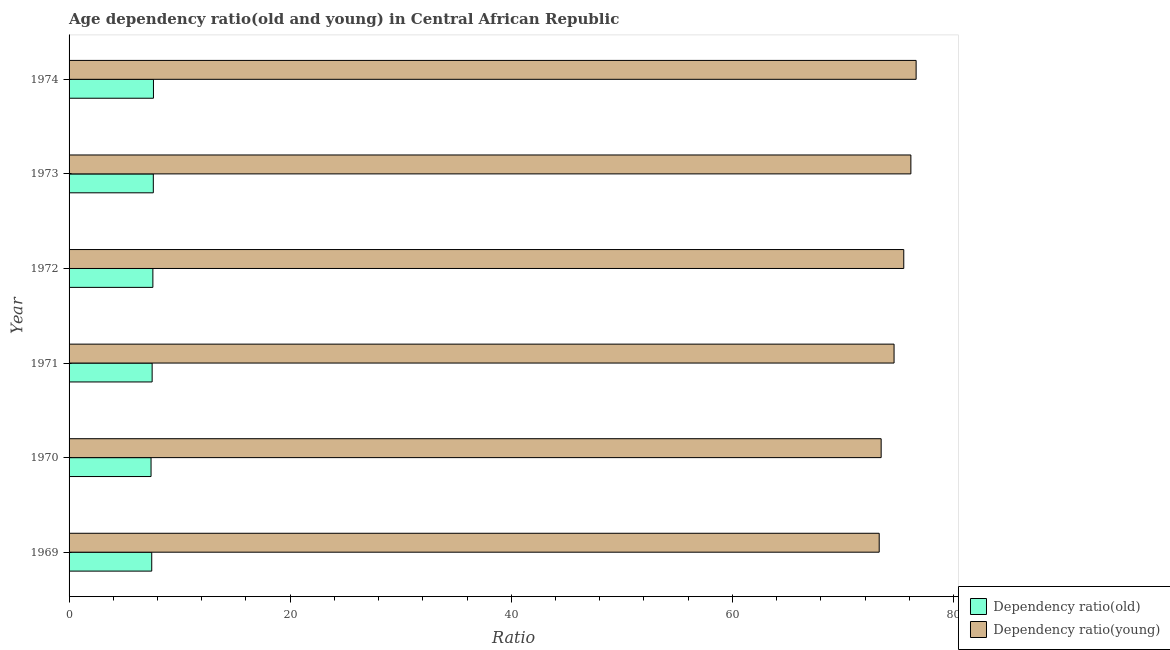How many groups of bars are there?
Make the answer very short. 6. What is the age dependency ratio(young) in 1969?
Provide a short and direct response. 73.27. Across all years, what is the maximum age dependency ratio(old)?
Your answer should be compact. 7.63. Across all years, what is the minimum age dependency ratio(young)?
Provide a short and direct response. 73.27. In which year was the age dependency ratio(old) maximum?
Keep it short and to the point. 1974. In which year was the age dependency ratio(young) minimum?
Your answer should be compact. 1969. What is the total age dependency ratio(young) in the graph?
Your answer should be compact. 449.59. What is the difference between the age dependency ratio(old) in 1969 and that in 1972?
Give a very brief answer. -0.1. What is the difference between the age dependency ratio(young) in 1973 and the age dependency ratio(old) in 1969?
Offer a very short reply. 68.66. What is the average age dependency ratio(old) per year?
Give a very brief answer. 7.54. In the year 1973, what is the difference between the age dependency ratio(young) and age dependency ratio(old)?
Provide a short and direct response. 68.52. In how many years, is the age dependency ratio(old) greater than 68 ?
Offer a terse response. 0. What is the ratio of the age dependency ratio(young) in 1970 to that in 1972?
Give a very brief answer. 0.97. Is the difference between the age dependency ratio(old) in 1972 and 1973 greater than the difference between the age dependency ratio(young) in 1972 and 1973?
Provide a succinct answer. Yes. What is the difference between the highest and the second highest age dependency ratio(young)?
Provide a short and direct response. 0.47. What is the difference between the highest and the lowest age dependency ratio(young)?
Ensure brevity in your answer.  3.34. Is the sum of the age dependency ratio(young) in 1973 and 1974 greater than the maximum age dependency ratio(old) across all years?
Your answer should be very brief. Yes. What does the 2nd bar from the top in 1971 represents?
Provide a short and direct response. Dependency ratio(old). What does the 1st bar from the bottom in 1970 represents?
Offer a terse response. Dependency ratio(old). How many bars are there?
Ensure brevity in your answer.  12. Are all the bars in the graph horizontal?
Keep it short and to the point. Yes. Are the values on the major ticks of X-axis written in scientific E-notation?
Offer a very short reply. No. Does the graph contain any zero values?
Your answer should be compact. No. Where does the legend appear in the graph?
Provide a succinct answer. Bottom right. How many legend labels are there?
Provide a short and direct response. 2. How are the legend labels stacked?
Ensure brevity in your answer.  Vertical. What is the title of the graph?
Make the answer very short. Age dependency ratio(old and young) in Central African Republic. What is the label or title of the X-axis?
Give a very brief answer. Ratio. What is the label or title of the Y-axis?
Provide a succinct answer. Year. What is the Ratio of Dependency ratio(old) in 1969?
Make the answer very short. 7.48. What is the Ratio in Dependency ratio(young) in 1969?
Keep it short and to the point. 73.27. What is the Ratio in Dependency ratio(old) in 1970?
Offer a terse response. 7.41. What is the Ratio in Dependency ratio(young) in 1970?
Keep it short and to the point. 73.45. What is the Ratio of Dependency ratio(old) in 1971?
Give a very brief answer. 7.51. What is the Ratio of Dependency ratio(young) in 1971?
Give a very brief answer. 74.62. What is the Ratio of Dependency ratio(old) in 1972?
Provide a short and direct response. 7.58. What is the Ratio in Dependency ratio(young) in 1972?
Make the answer very short. 75.5. What is the Ratio in Dependency ratio(old) in 1973?
Make the answer very short. 7.62. What is the Ratio in Dependency ratio(young) in 1973?
Offer a very short reply. 76.14. What is the Ratio of Dependency ratio(old) in 1974?
Make the answer very short. 7.63. What is the Ratio in Dependency ratio(young) in 1974?
Ensure brevity in your answer.  76.61. Across all years, what is the maximum Ratio of Dependency ratio(old)?
Your answer should be compact. 7.63. Across all years, what is the maximum Ratio in Dependency ratio(young)?
Provide a succinct answer. 76.61. Across all years, what is the minimum Ratio in Dependency ratio(old)?
Your answer should be very brief. 7.41. Across all years, what is the minimum Ratio in Dependency ratio(young)?
Your answer should be very brief. 73.27. What is the total Ratio in Dependency ratio(old) in the graph?
Make the answer very short. 45.24. What is the total Ratio in Dependency ratio(young) in the graph?
Provide a succinct answer. 449.59. What is the difference between the Ratio of Dependency ratio(old) in 1969 and that in 1970?
Ensure brevity in your answer.  0.06. What is the difference between the Ratio in Dependency ratio(young) in 1969 and that in 1970?
Your answer should be very brief. -0.18. What is the difference between the Ratio of Dependency ratio(old) in 1969 and that in 1971?
Give a very brief answer. -0.04. What is the difference between the Ratio of Dependency ratio(young) in 1969 and that in 1971?
Your answer should be very brief. -1.34. What is the difference between the Ratio of Dependency ratio(old) in 1969 and that in 1972?
Offer a very short reply. -0.1. What is the difference between the Ratio in Dependency ratio(young) in 1969 and that in 1972?
Keep it short and to the point. -2.22. What is the difference between the Ratio in Dependency ratio(old) in 1969 and that in 1973?
Ensure brevity in your answer.  -0.14. What is the difference between the Ratio of Dependency ratio(young) in 1969 and that in 1973?
Your answer should be very brief. -2.86. What is the difference between the Ratio in Dependency ratio(old) in 1969 and that in 1974?
Give a very brief answer. -0.15. What is the difference between the Ratio in Dependency ratio(young) in 1969 and that in 1974?
Your answer should be compact. -3.34. What is the difference between the Ratio in Dependency ratio(old) in 1970 and that in 1971?
Keep it short and to the point. -0.1. What is the difference between the Ratio in Dependency ratio(young) in 1970 and that in 1971?
Your response must be concise. -1.17. What is the difference between the Ratio in Dependency ratio(old) in 1970 and that in 1972?
Keep it short and to the point. -0.17. What is the difference between the Ratio of Dependency ratio(young) in 1970 and that in 1972?
Your response must be concise. -2.04. What is the difference between the Ratio in Dependency ratio(old) in 1970 and that in 1973?
Give a very brief answer. -0.2. What is the difference between the Ratio in Dependency ratio(young) in 1970 and that in 1973?
Make the answer very short. -2.69. What is the difference between the Ratio in Dependency ratio(old) in 1970 and that in 1974?
Provide a succinct answer. -0.22. What is the difference between the Ratio in Dependency ratio(young) in 1970 and that in 1974?
Give a very brief answer. -3.16. What is the difference between the Ratio in Dependency ratio(old) in 1971 and that in 1972?
Provide a short and direct response. -0.07. What is the difference between the Ratio in Dependency ratio(young) in 1971 and that in 1972?
Give a very brief answer. -0.88. What is the difference between the Ratio in Dependency ratio(old) in 1971 and that in 1973?
Your answer should be very brief. -0.11. What is the difference between the Ratio of Dependency ratio(young) in 1971 and that in 1973?
Make the answer very short. -1.52. What is the difference between the Ratio of Dependency ratio(old) in 1971 and that in 1974?
Provide a succinct answer. -0.12. What is the difference between the Ratio in Dependency ratio(young) in 1971 and that in 1974?
Your answer should be very brief. -2. What is the difference between the Ratio of Dependency ratio(old) in 1972 and that in 1973?
Provide a short and direct response. -0.04. What is the difference between the Ratio in Dependency ratio(young) in 1972 and that in 1973?
Give a very brief answer. -0.64. What is the difference between the Ratio in Dependency ratio(old) in 1972 and that in 1974?
Provide a succinct answer. -0.05. What is the difference between the Ratio of Dependency ratio(young) in 1972 and that in 1974?
Give a very brief answer. -1.12. What is the difference between the Ratio in Dependency ratio(old) in 1973 and that in 1974?
Provide a short and direct response. -0.01. What is the difference between the Ratio of Dependency ratio(young) in 1973 and that in 1974?
Ensure brevity in your answer.  -0.47. What is the difference between the Ratio of Dependency ratio(old) in 1969 and the Ratio of Dependency ratio(young) in 1970?
Ensure brevity in your answer.  -65.97. What is the difference between the Ratio in Dependency ratio(old) in 1969 and the Ratio in Dependency ratio(young) in 1971?
Provide a succinct answer. -67.14. What is the difference between the Ratio in Dependency ratio(old) in 1969 and the Ratio in Dependency ratio(young) in 1972?
Make the answer very short. -68.02. What is the difference between the Ratio of Dependency ratio(old) in 1969 and the Ratio of Dependency ratio(young) in 1973?
Offer a terse response. -68.66. What is the difference between the Ratio in Dependency ratio(old) in 1969 and the Ratio in Dependency ratio(young) in 1974?
Provide a short and direct response. -69.14. What is the difference between the Ratio of Dependency ratio(old) in 1970 and the Ratio of Dependency ratio(young) in 1971?
Provide a succinct answer. -67.2. What is the difference between the Ratio of Dependency ratio(old) in 1970 and the Ratio of Dependency ratio(young) in 1972?
Your answer should be compact. -68.08. What is the difference between the Ratio in Dependency ratio(old) in 1970 and the Ratio in Dependency ratio(young) in 1973?
Offer a terse response. -68.72. What is the difference between the Ratio of Dependency ratio(old) in 1970 and the Ratio of Dependency ratio(young) in 1974?
Your response must be concise. -69.2. What is the difference between the Ratio of Dependency ratio(old) in 1971 and the Ratio of Dependency ratio(young) in 1972?
Keep it short and to the point. -67.98. What is the difference between the Ratio in Dependency ratio(old) in 1971 and the Ratio in Dependency ratio(young) in 1973?
Your response must be concise. -68.63. What is the difference between the Ratio in Dependency ratio(old) in 1971 and the Ratio in Dependency ratio(young) in 1974?
Offer a very short reply. -69.1. What is the difference between the Ratio of Dependency ratio(old) in 1972 and the Ratio of Dependency ratio(young) in 1973?
Ensure brevity in your answer.  -68.56. What is the difference between the Ratio of Dependency ratio(old) in 1972 and the Ratio of Dependency ratio(young) in 1974?
Provide a short and direct response. -69.03. What is the difference between the Ratio of Dependency ratio(old) in 1973 and the Ratio of Dependency ratio(young) in 1974?
Keep it short and to the point. -68.99. What is the average Ratio of Dependency ratio(old) per year?
Keep it short and to the point. 7.54. What is the average Ratio in Dependency ratio(young) per year?
Your answer should be compact. 74.93. In the year 1969, what is the difference between the Ratio of Dependency ratio(old) and Ratio of Dependency ratio(young)?
Your response must be concise. -65.8. In the year 1970, what is the difference between the Ratio in Dependency ratio(old) and Ratio in Dependency ratio(young)?
Provide a short and direct response. -66.04. In the year 1971, what is the difference between the Ratio in Dependency ratio(old) and Ratio in Dependency ratio(young)?
Give a very brief answer. -67.11. In the year 1972, what is the difference between the Ratio in Dependency ratio(old) and Ratio in Dependency ratio(young)?
Your answer should be compact. -67.92. In the year 1973, what is the difference between the Ratio in Dependency ratio(old) and Ratio in Dependency ratio(young)?
Offer a terse response. -68.52. In the year 1974, what is the difference between the Ratio in Dependency ratio(old) and Ratio in Dependency ratio(young)?
Keep it short and to the point. -68.98. What is the ratio of the Ratio in Dependency ratio(old) in 1969 to that in 1970?
Your response must be concise. 1.01. What is the ratio of the Ratio of Dependency ratio(young) in 1969 to that in 1971?
Keep it short and to the point. 0.98. What is the ratio of the Ratio in Dependency ratio(old) in 1969 to that in 1972?
Ensure brevity in your answer.  0.99. What is the ratio of the Ratio of Dependency ratio(young) in 1969 to that in 1972?
Provide a succinct answer. 0.97. What is the ratio of the Ratio in Dependency ratio(old) in 1969 to that in 1973?
Your response must be concise. 0.98. What is the ratio of the Ratio in Dependency ratio(young) in 1969 to that in 1973?
Provide a short and direct response. 0.96. What is the ratio of the Ratio of Dependency ratio(old) in 1969 to that in 1974?
Give a very brief answer. 0.98. What is the ratio of the Ratio in Dependency ratio(young) in 1969 to that in 1974?
Your response must be concise. 0.96. What is the ratio of the Ratio of Dependency ratio(old) in 1970 to that in 1971?
Your answer should be very brief. 0.99. What is the ratio of the Ratio in Dependency ratio(young) in 1970 to that in 1971?
Provide a short and direct response. 0.98. What is the ratio of the Ratio in Dependency ratio(old) in 1970 to that in 1972?
Keep it short and to the point. 0.98. What is the ratio of the Ratio of Dependency ratio(young) in 1970 to that in 1972?
Give a very brief answer. 0.97. What is the ratio of the Ratio in Dependency ratio(old) in 1970 to that in 1973?
Your answer should be very brief. 0.97. What is the ratio of the Ratio of Dependency ratio(young) in 1970 to that in 1973?
Offer a terse response. 0.96. What is the ratio of the Ratio in Dependency ratio(old) in 1970 to that in 1974?
Your answer should be compact. 0.97. What is the ratio of the Ratio of Dependency ratio(young) in 1970 to that in 1974?
Provide a succinct answer. 0.96. What is the ratio of the Ratio of Dependency ratio(young) in 1971 to that in 1972?
Ensure brevity in your answer.  0.99. What is the ratio of the Ratio in Dependency ratio(young) in 1971 to that in 1973?
Offer a terse response. 0.98. What is the ratio of the Ratio of Dependency ratio(old) in 1971 to that in 1974?
Provide a short and direct response. 0.98. What is the ratio of the Ratio of Dependency ratio(old) in 1972 to that in 1973?
Your answer should be very brief. 0.99. What is the ratio of the Ratio of Dependency ratio(old) in 1972 to that in 1974?
Ensure brevity in your answer.  0.99. What is the ratio of the Ratio of Dependency ratio(young) in 1972 to that in 1974?
Your answer should be compact. 0.99. What is the difference between the highest and the second highest Ratio of Dependency ratio(old)?
Make the answer very short. 0.01. What is the difference between the highest and the second highest Ratio of Dependency ratio(young)?
Make the answer very short. 0.47. What is the difference between the highest and the lowest Ratio of Dependency ratio(old)?
Your answer should be compact. 0.22. What is the difference between the highest and the lowest Ratio of Dependency ratio(young)?
Provide a short and direct response. 3.34. 